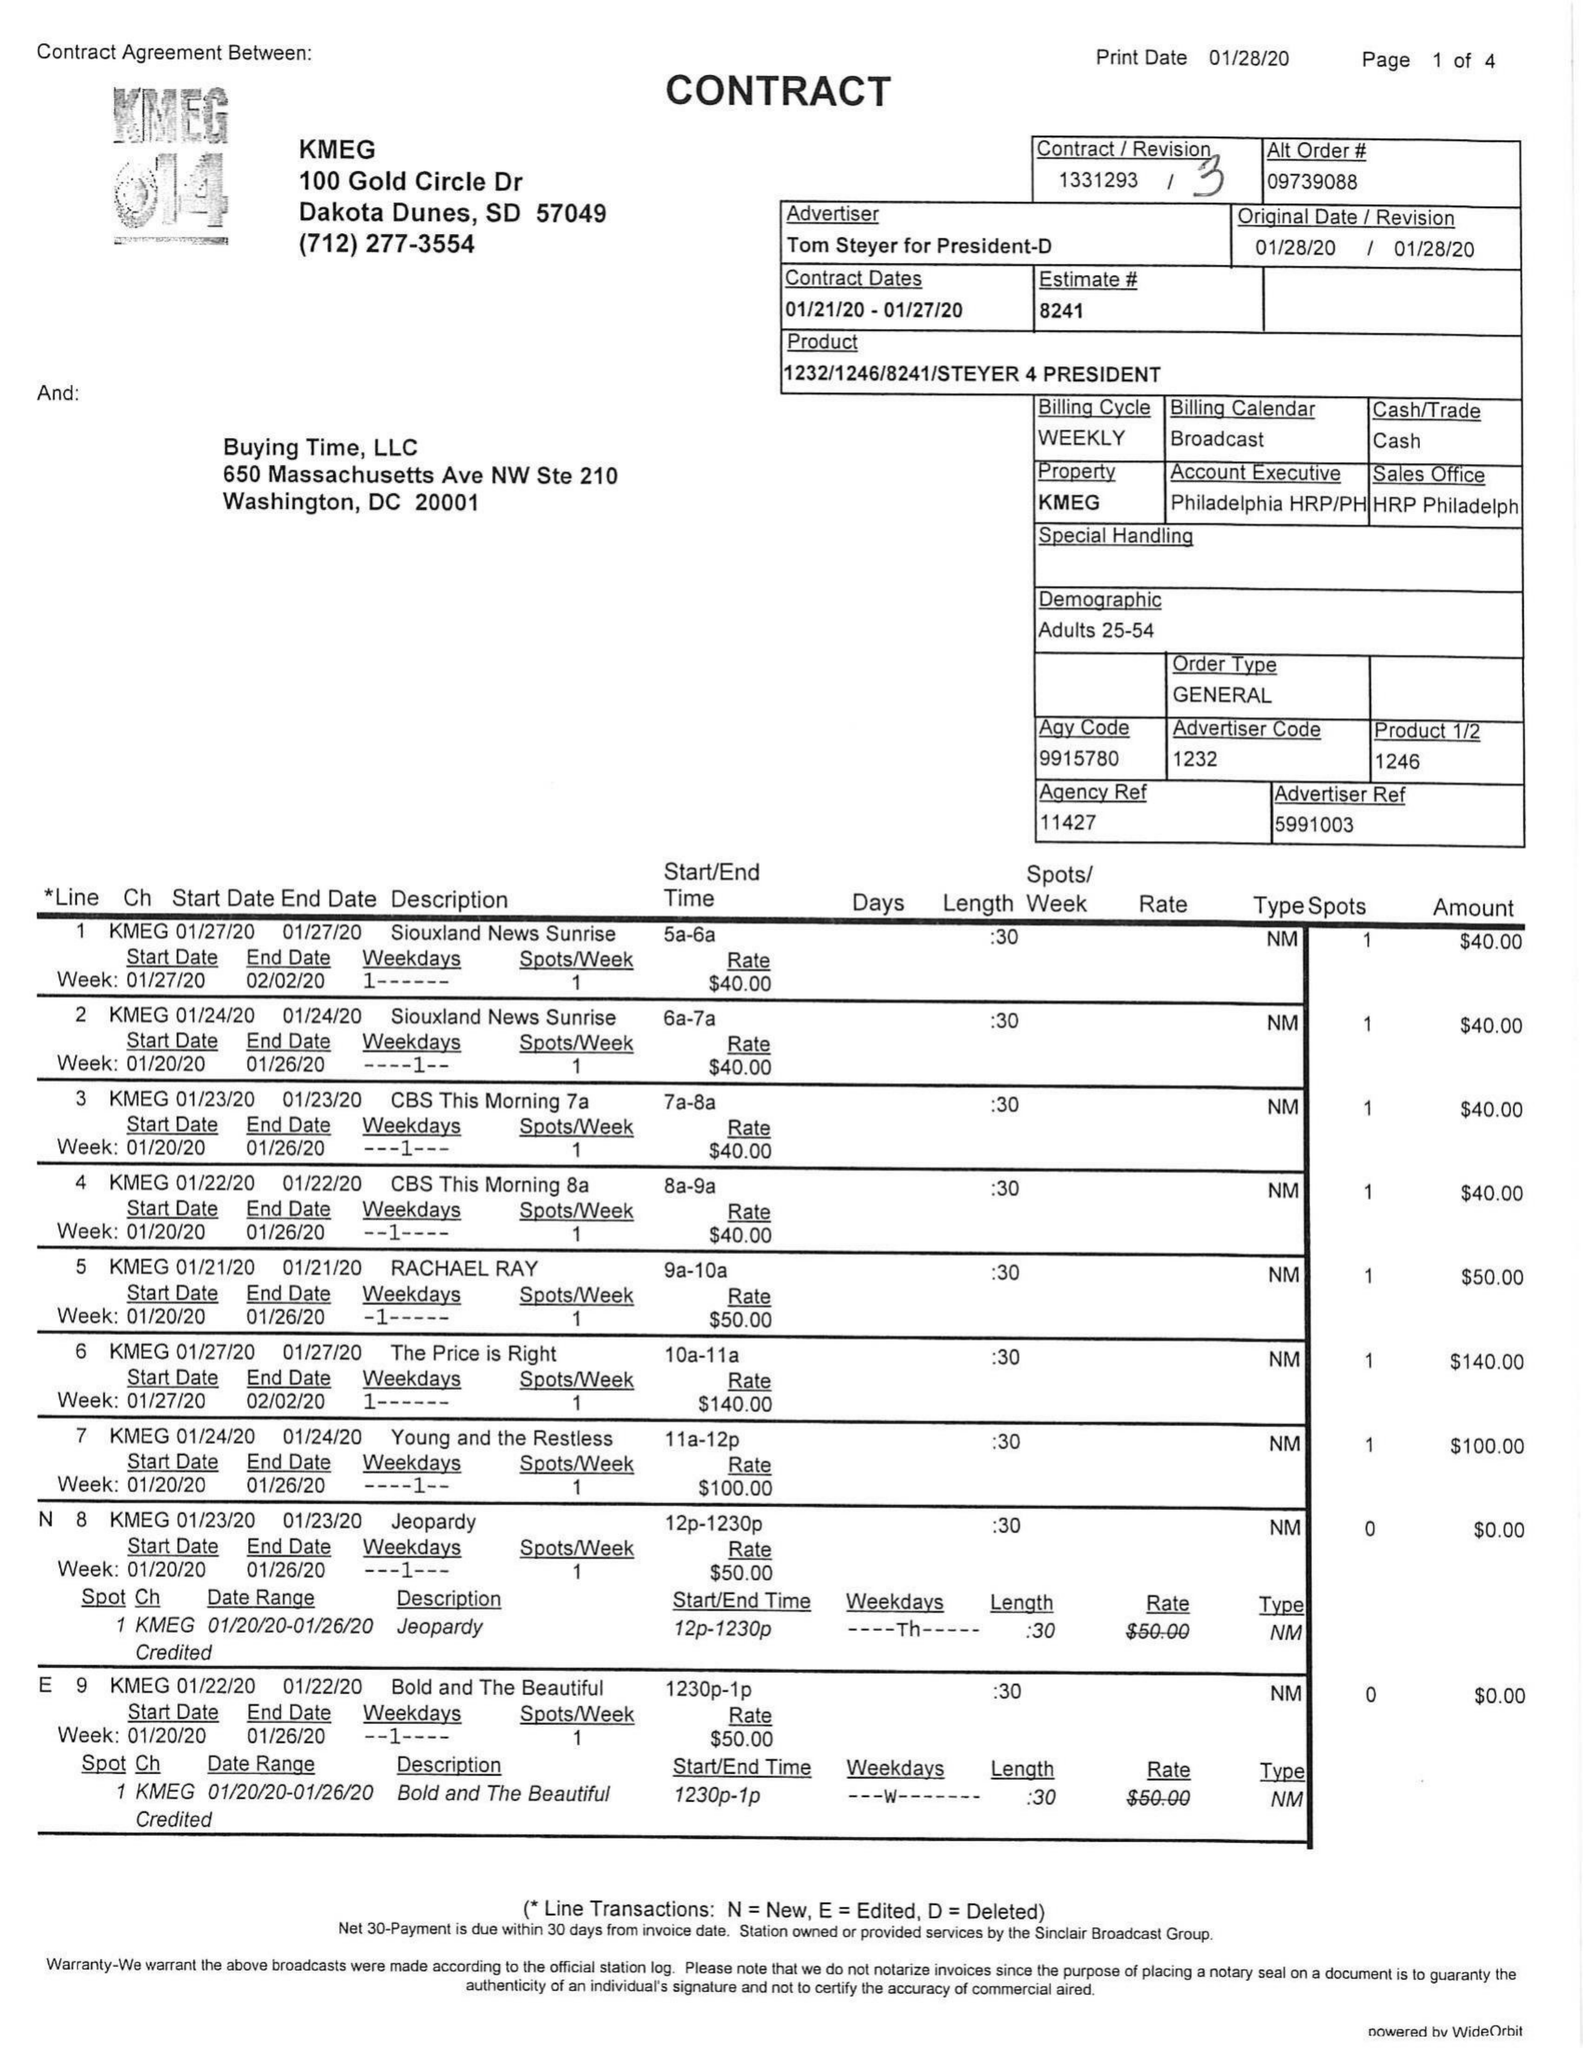What is the value for the contract_num?
Answer the question using a single word or phrase. 1331293 